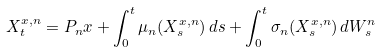Convert formula to latex. <formula><loc_0><loc_0><loc_500><loc_500>X _ { t } ^ { x , n } = P _ { n } x + \int _ { 0 } ^ { t } \mu _ { n } ( X ^ { x , n } _ { s } ) \, d s + \int _ { 0 } ^ { t } \sigma _ { n } ( X ^ { x , n } _ { s } ) \, d W ^ { n } _ { s }</formula> 